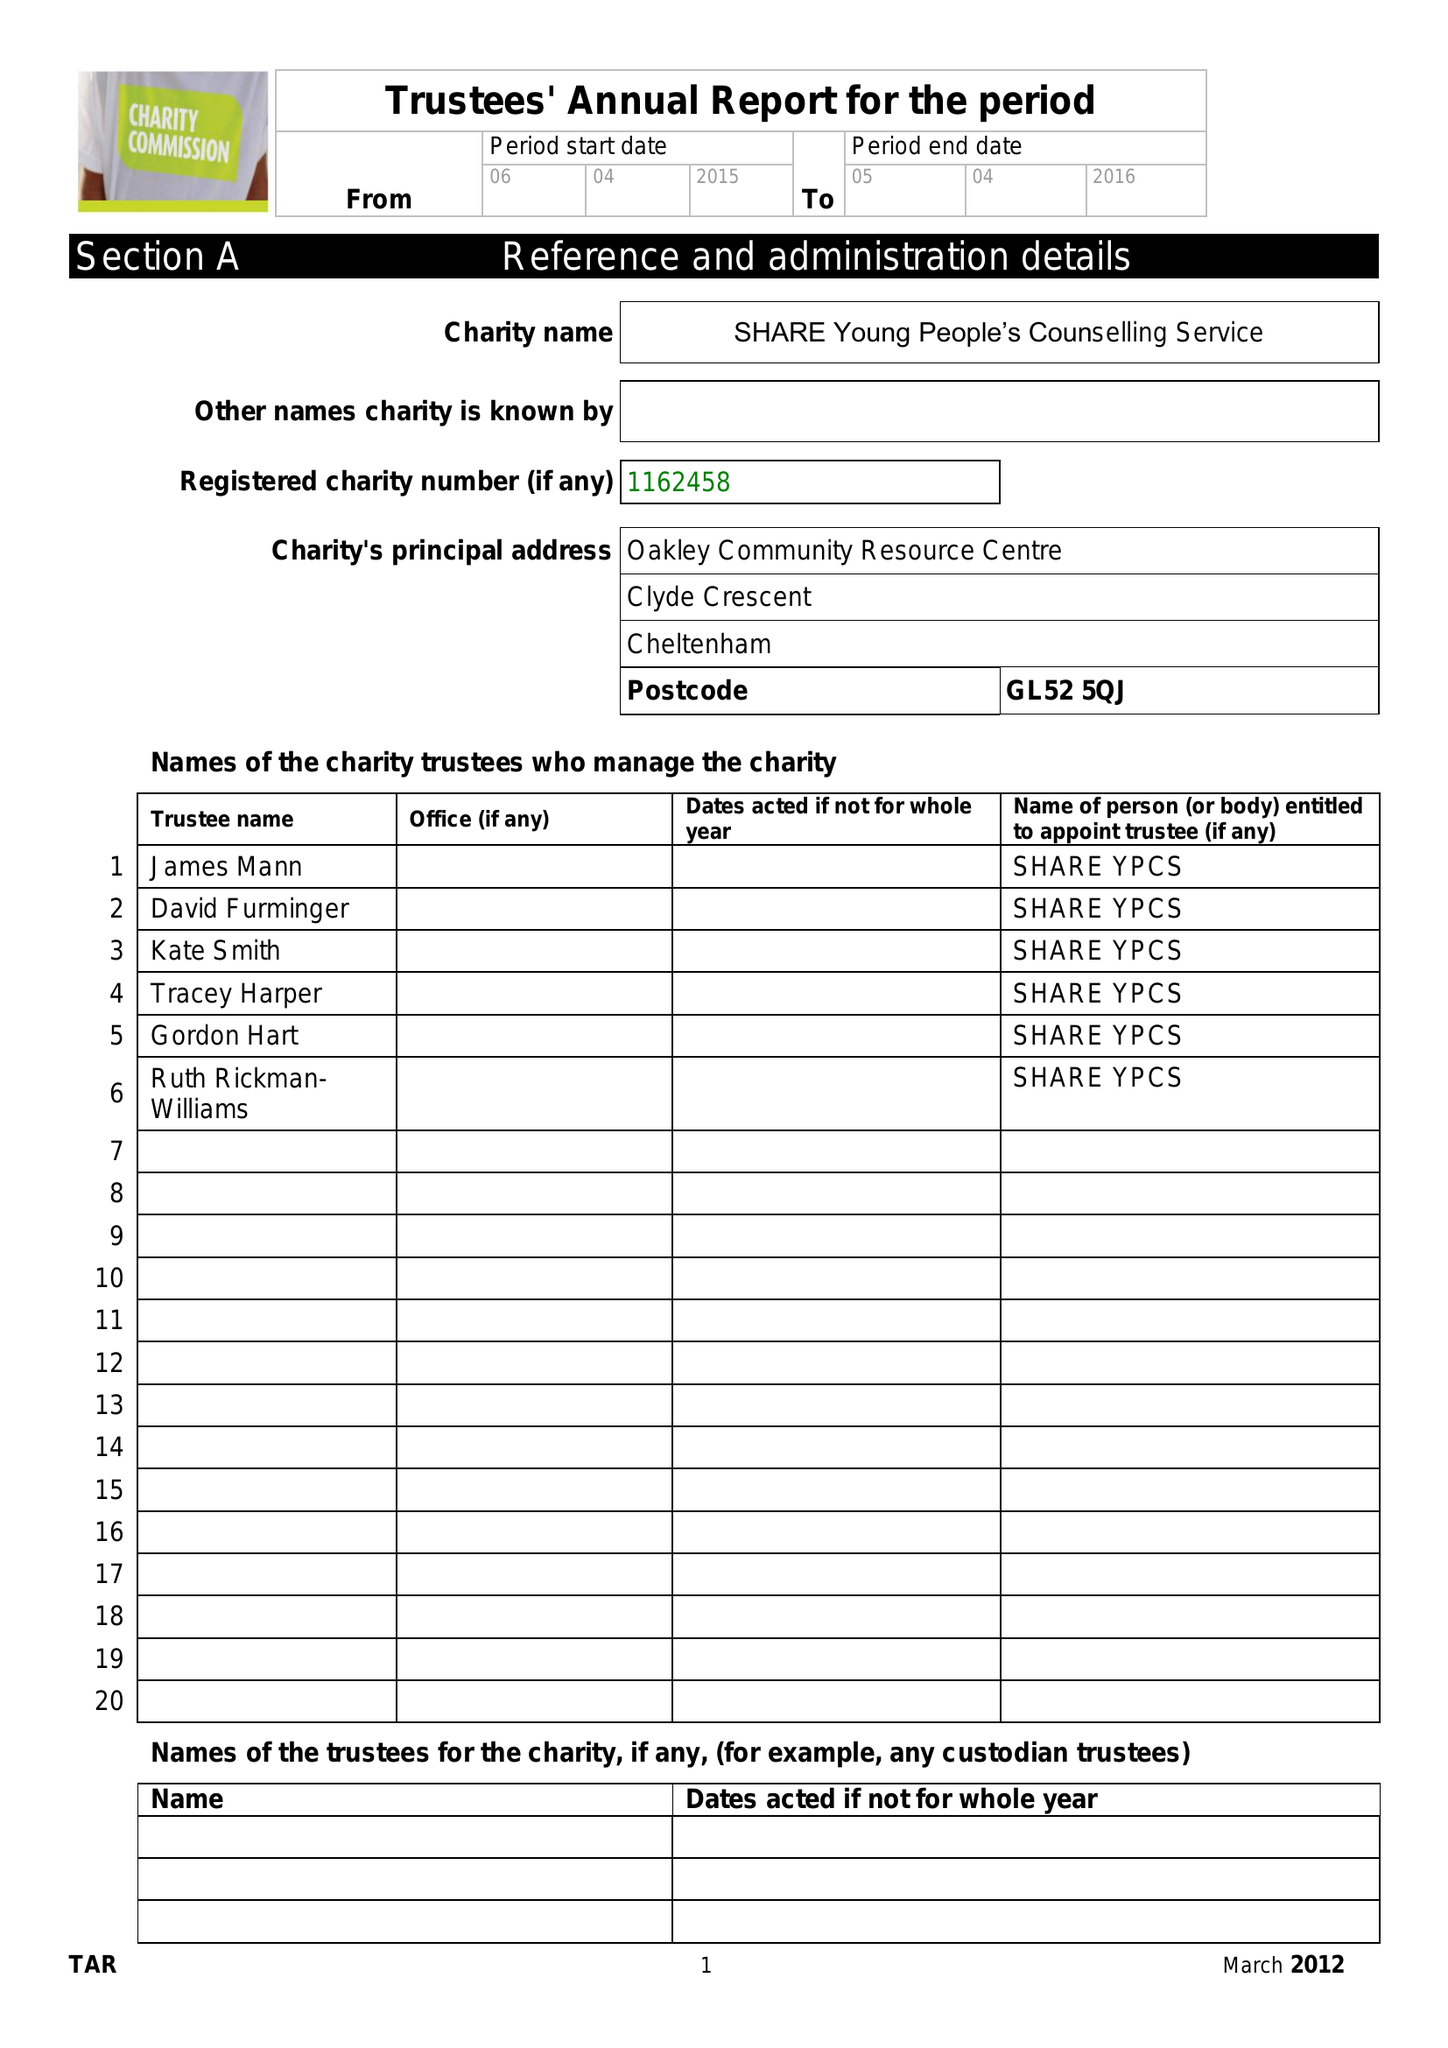What is the value for the charity_number?
Answer the question using a single word or phrase. 1162458 